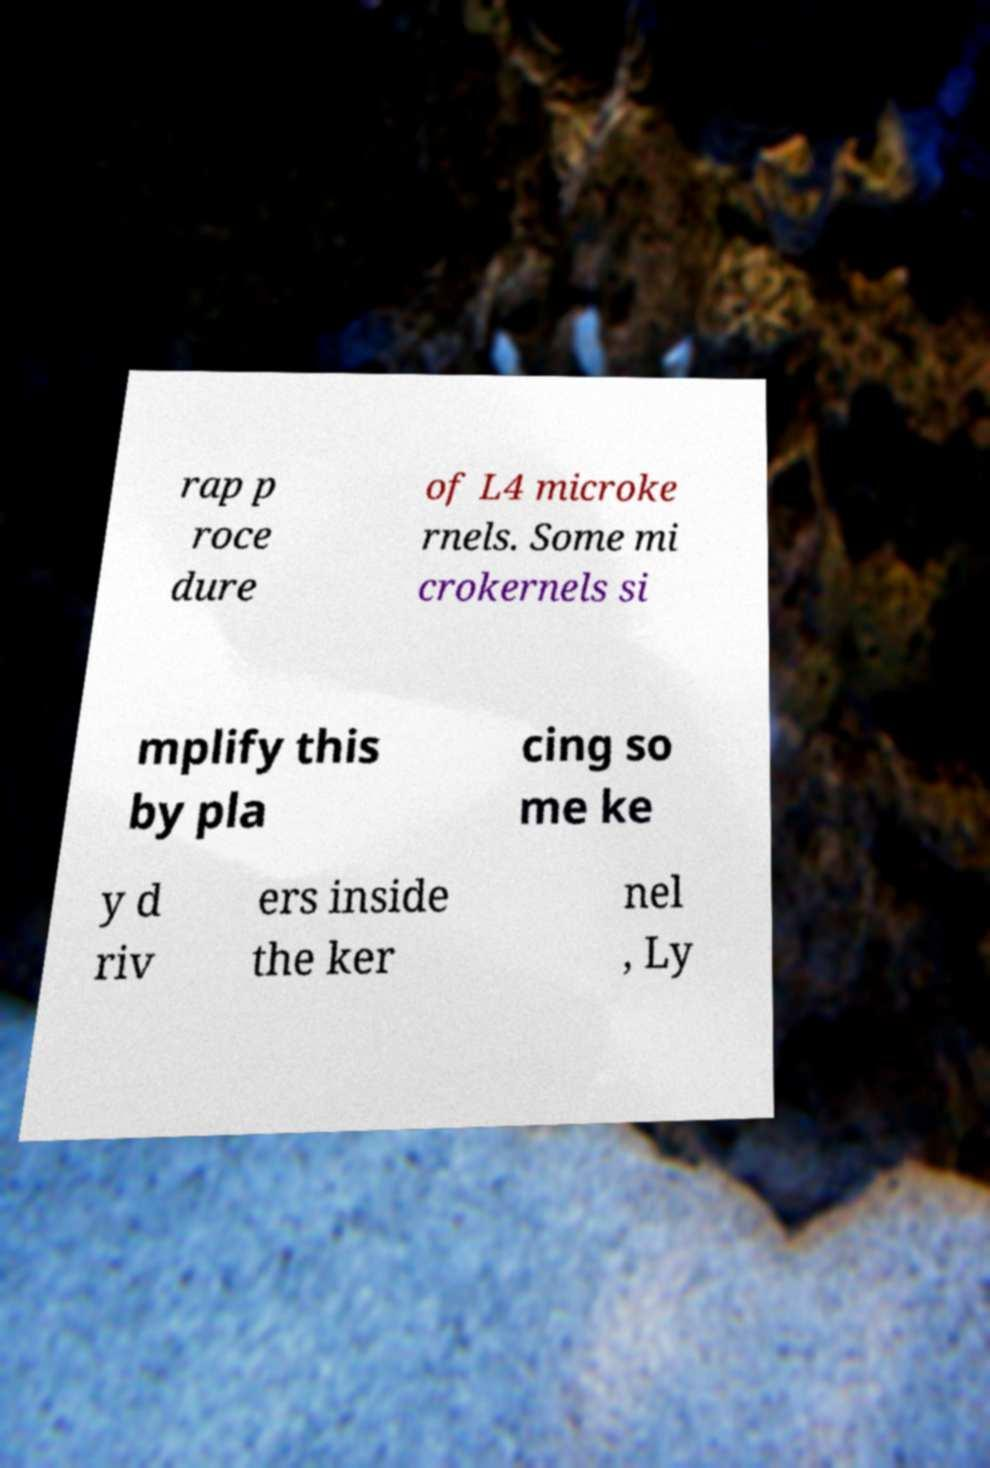Can you accurately transcribe the text from the provided image for me? rap p roce dure of L4 microke rnels. Some mi crokernels si mplify this by pla cing so me ke y d riv ers inside the ker nel , Ly 